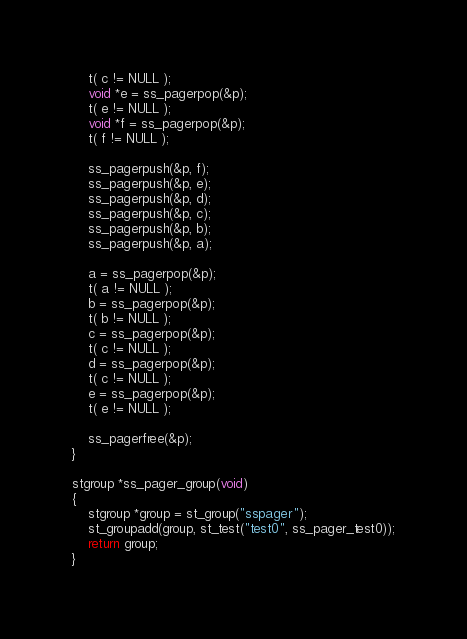Convert code to text. <code><loc_0><loc_0><loc_500><loc_500><_C_>	t( c != NULL );
	void *e = ss_pagerpop(&p);
	t( e != NULL );
	void *f = ss_pagerpop(&p);
	t( f != NULL );

	ss_pagerpush(&p, f);
	ss_pagerpush(&p, e);
	ss_pagerpush(&p, d);
	ss_pagerpush(&p, c);
	ss_pagerpush(&p, b);
	ss_pagerpush(&p, a);

	a = ss_pagerpop(&p);
	t( a != NULL );
	b = ss_pagerpop(&p);
	t( b != NULL );
	c = ss_pagerpop(&p);
	t( c != NULL );
	d = ss_pagerpop(&p);
	t( c != NULL );
	e = ss_pagerpop(&p);
	t( e != NULL );

	ss_pagerfree(&p);
}

stgroup *ss_pager_group(void)
{
	stgroup *group = st_group("sspager");
	st_groupadd(group, st_test("test0", ss_pager_test0));
	return group;
}
</code> 